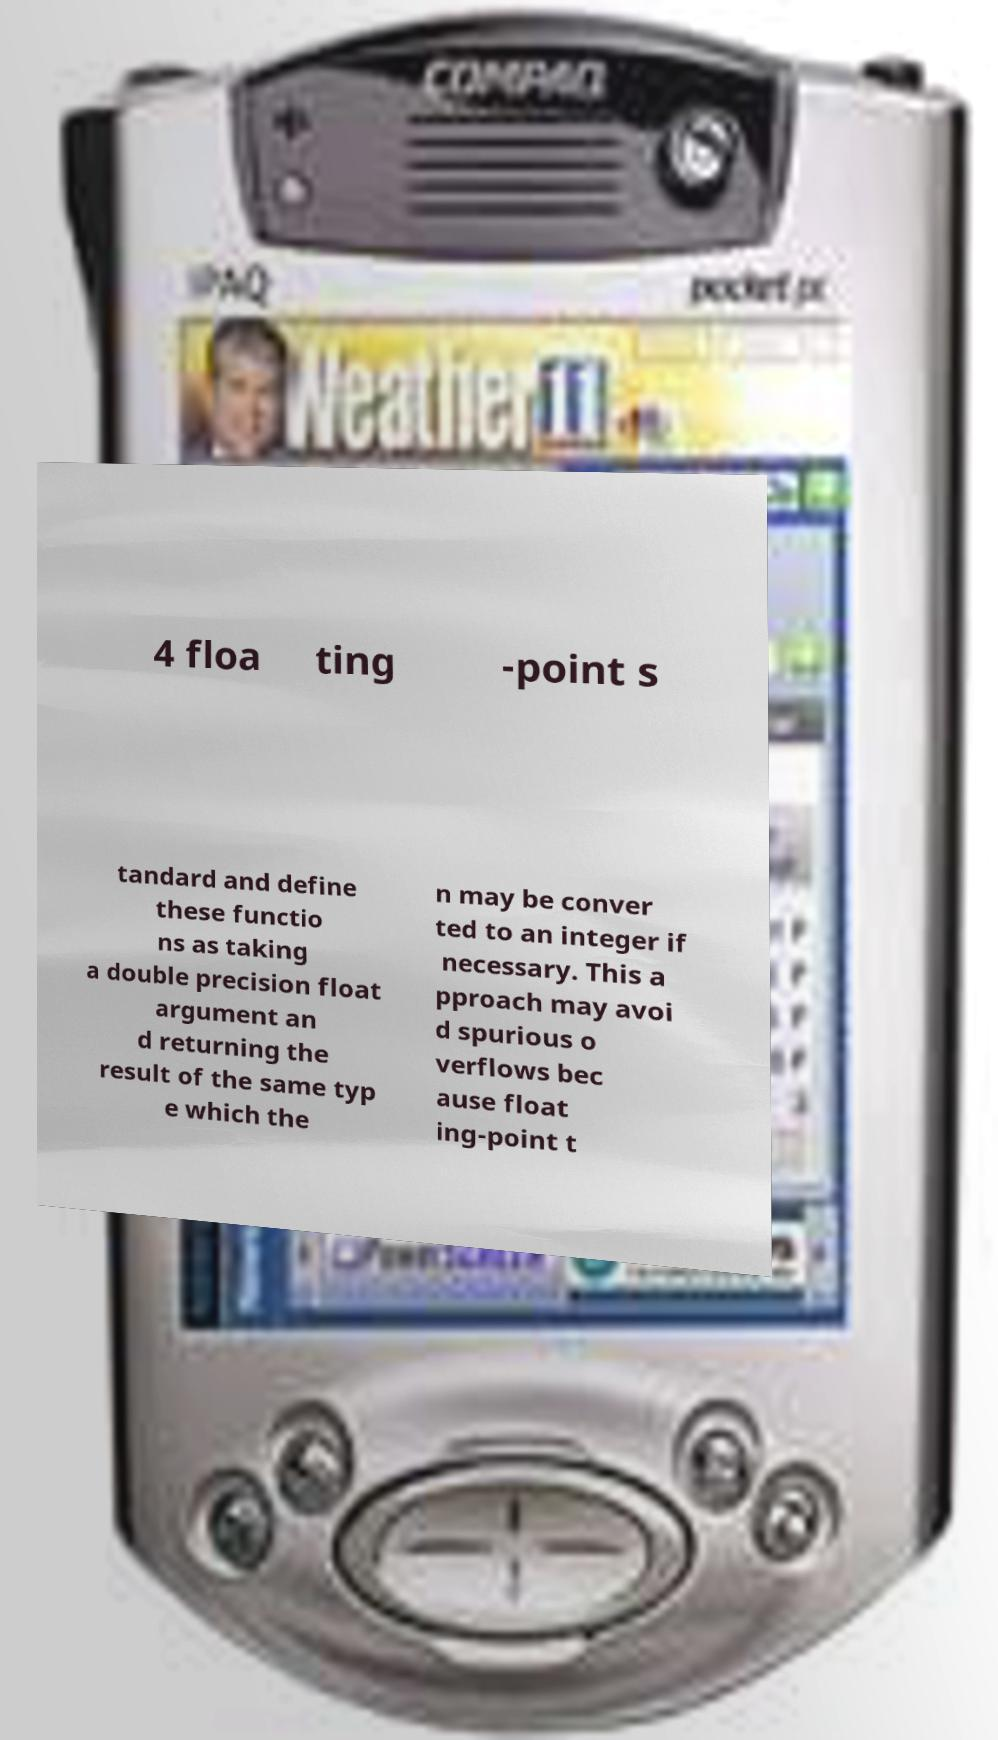Can you read and provide the text displayed in the image?This photo seems to have some interesting text. Can you extract and type it out for me? 4 floa ting -point s tandard and define these functio ns as taking a double precision float argument an d returning the result of the same typ e which the n may be conver ted to an integer if necessary. This a pproach may avoi d spurious o verflows bec ause float ing-point t 